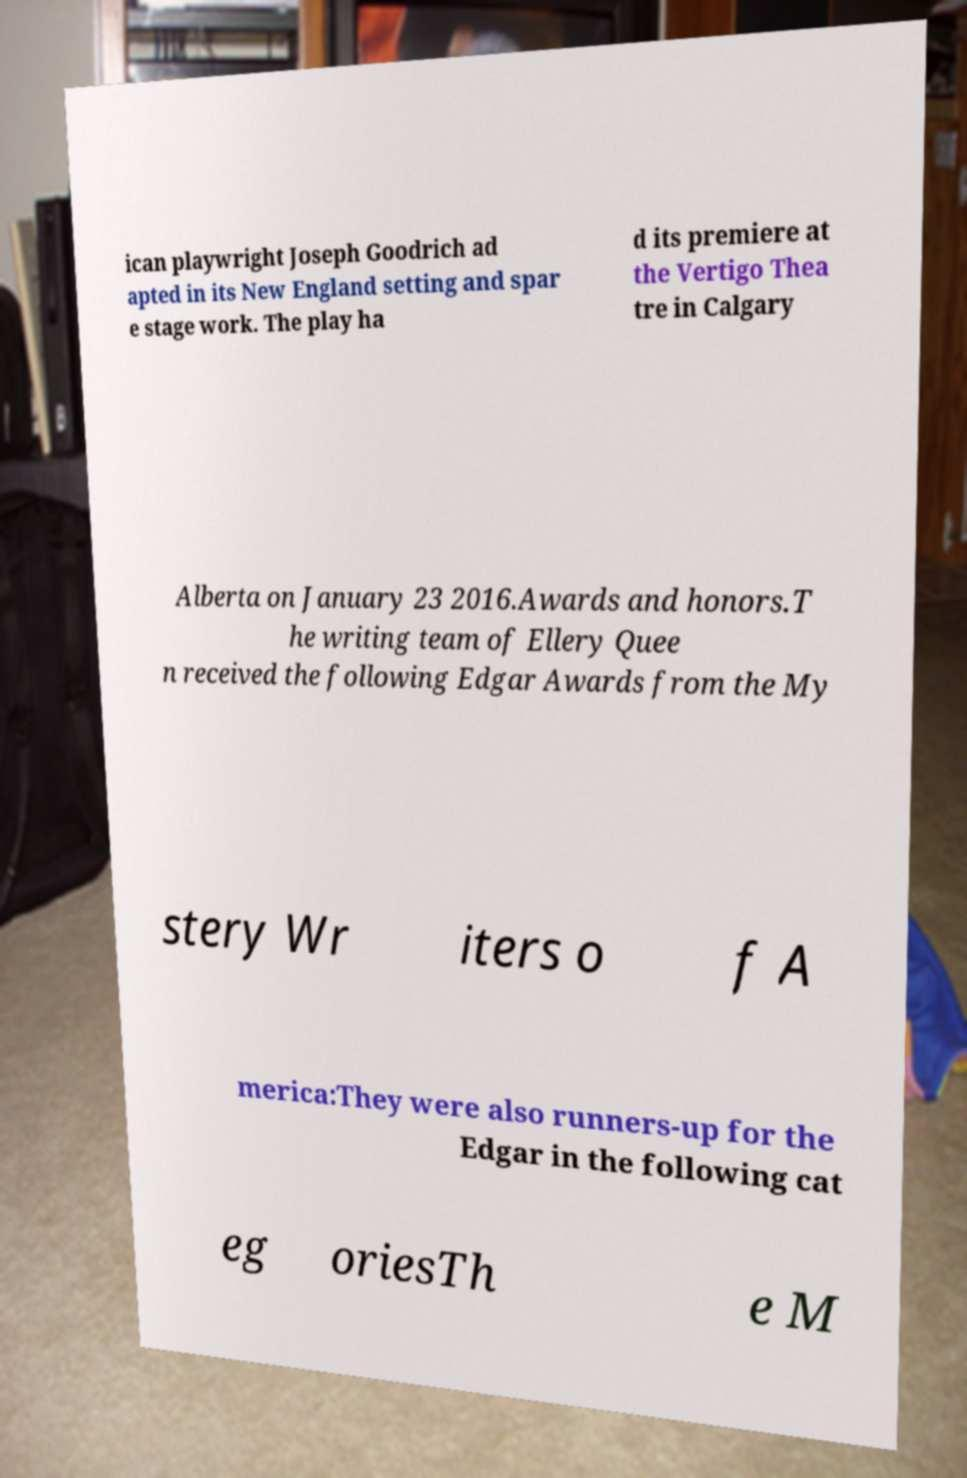I need the written content from this picture converted into text. Can you do that? ican playwright Joseph Goodrich ad apted in its New England setting and spar e stage work. The play ha d its premiere at the Vertigo Thea tre in Calgary Alberta on January 23 2016.Awards and honors.T he writing team of Ellery Quee n received the following Edgar Awards from the My stery Wr iters o f A merica:They were also runners-up for the Edgar in the following cat eg oriesTh e M 